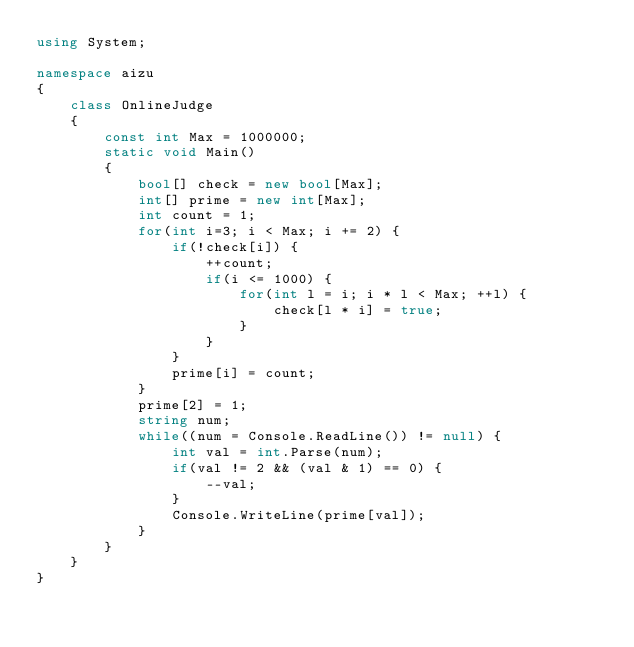Convert code to text. <code><loc_0><loc_0><loc_500><loc_500><_C#_>using System;
 
namespace aizu
{
    class OnlineJudge
    {
        const int Max = 1000000;
        static void Main()
        {
            bool[] check = new bool[Max];
            int[] prime = new int[Max];
            int count = 1;
            for(int i=3; i < Max; i += 2) {
                if(!check[i]) {
                    ++count;
                    if(i <= 1000) {
                        for(int l = i; i * l < Max; ++l) {
                            check[l * i] = true;
                        }
                    }
                }
                prime[i] = count;
            }
            prime[2] = 1;
            string num;
            while((num = Console.ReadLine()) != null) {
                int val = int.Parse(num);
                if(val != 2 && (val & 1) == 0) {
                    --val;
                }
                Console.WriteLine(prime[val]);
            }
        }
    }
}</code> 